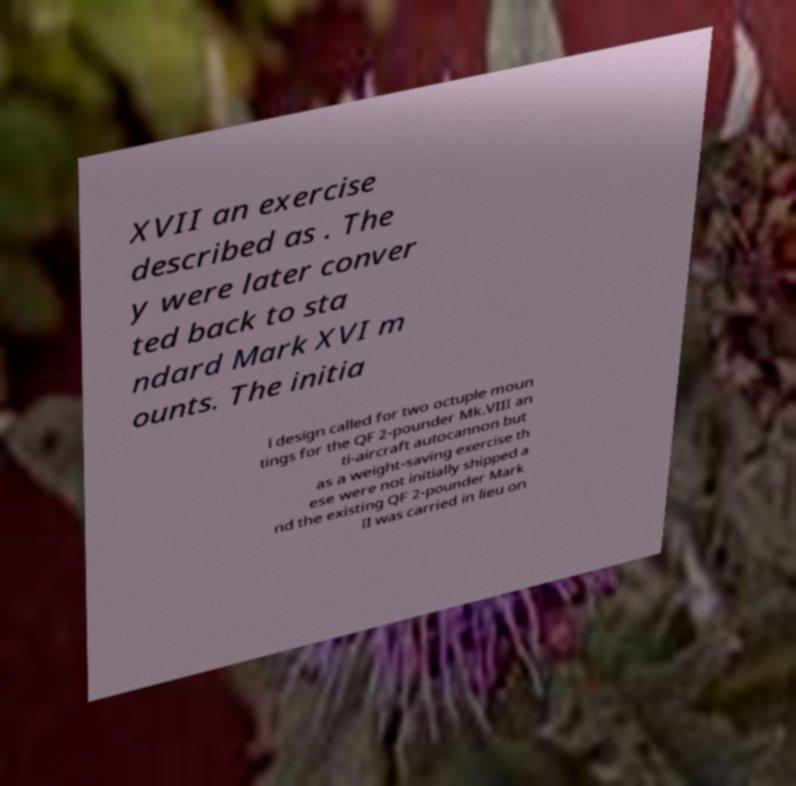I need the written content from this picture converted into text. Can you do that? XVII an exercise described as . The y were later conver ted back to sta ndard Mark XVI m ounts. The initia l design called for two octuple moun tings for the QF 2-pounder Mk.VIII an ti-aircraft autocannon but as a weight-saving exercise th ese were not initially shipped a nd the existing QF 2-pounder Mark II was carried in lieu on 